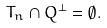Convert formula to latex. <formula><loc_0><loc_0><loc_500><loc_500>T _ { n } \cap Q ^ { \bot } = \emptyset .</formula> 